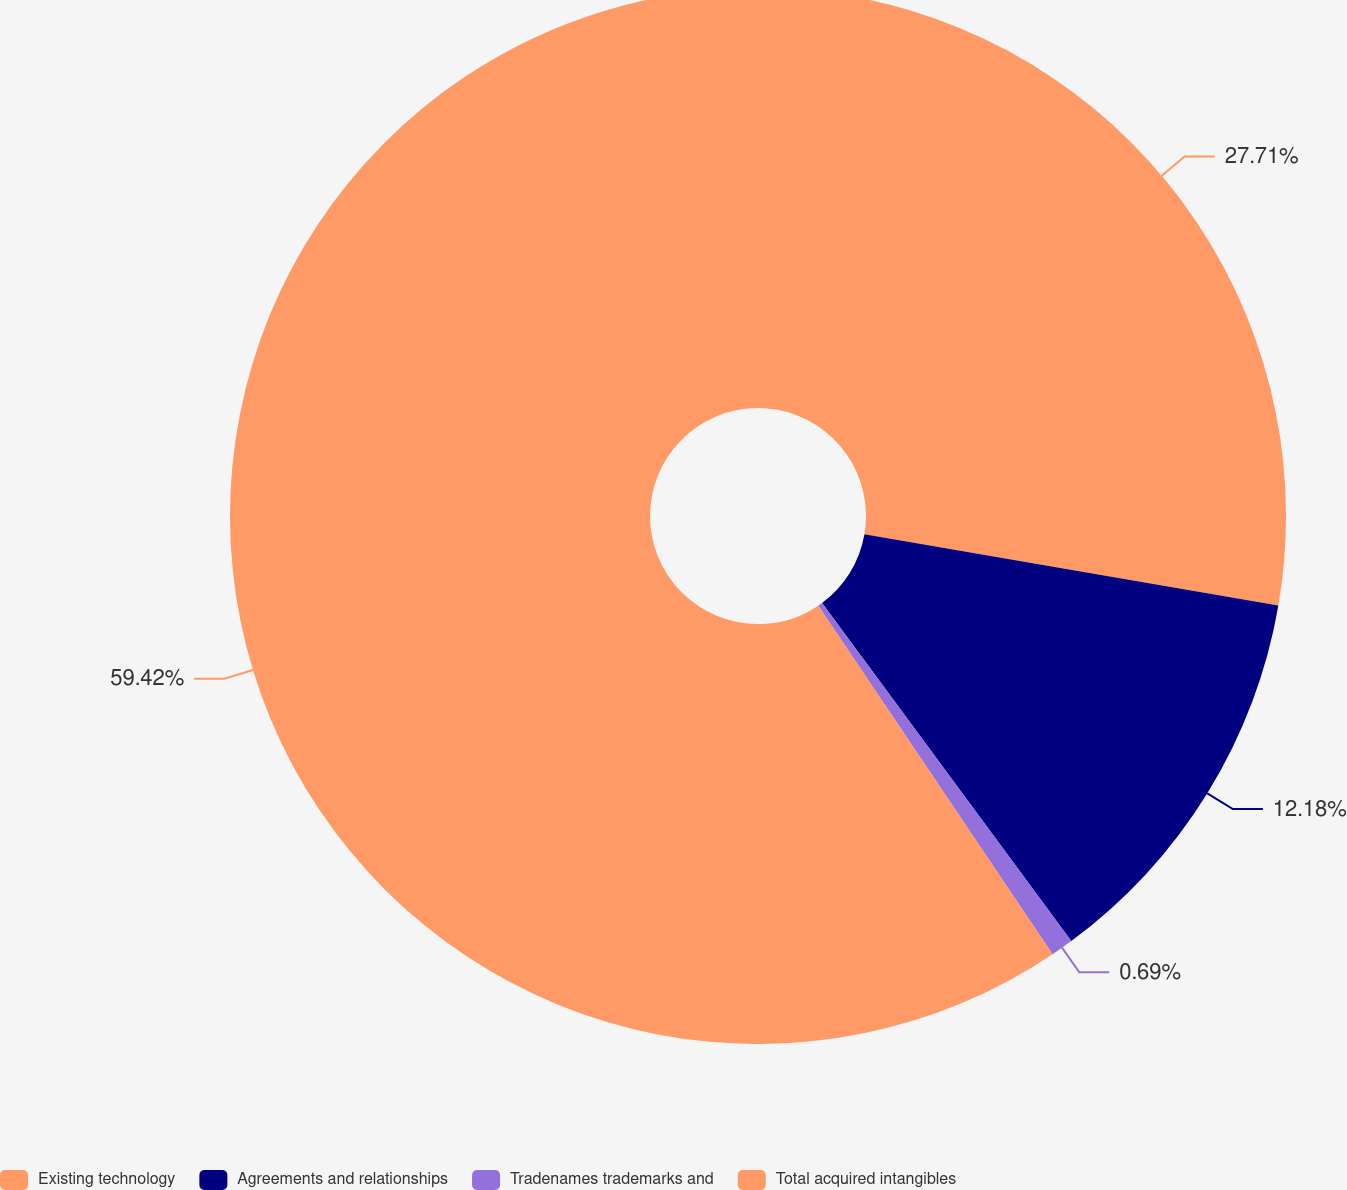Convert chart to OTSL. <chart><loc_0><loc_0><loc_500><loc_500><pie_chart><fcel>Existing technology<fcel>Agreements and relationships<fcel>Tradenames trademarks and<fcel>Total acquired intangibles<nl><fcel>27.71%<fcel>12.18%<fcel>0.69%<fcel>59.42%<nl></chart> 